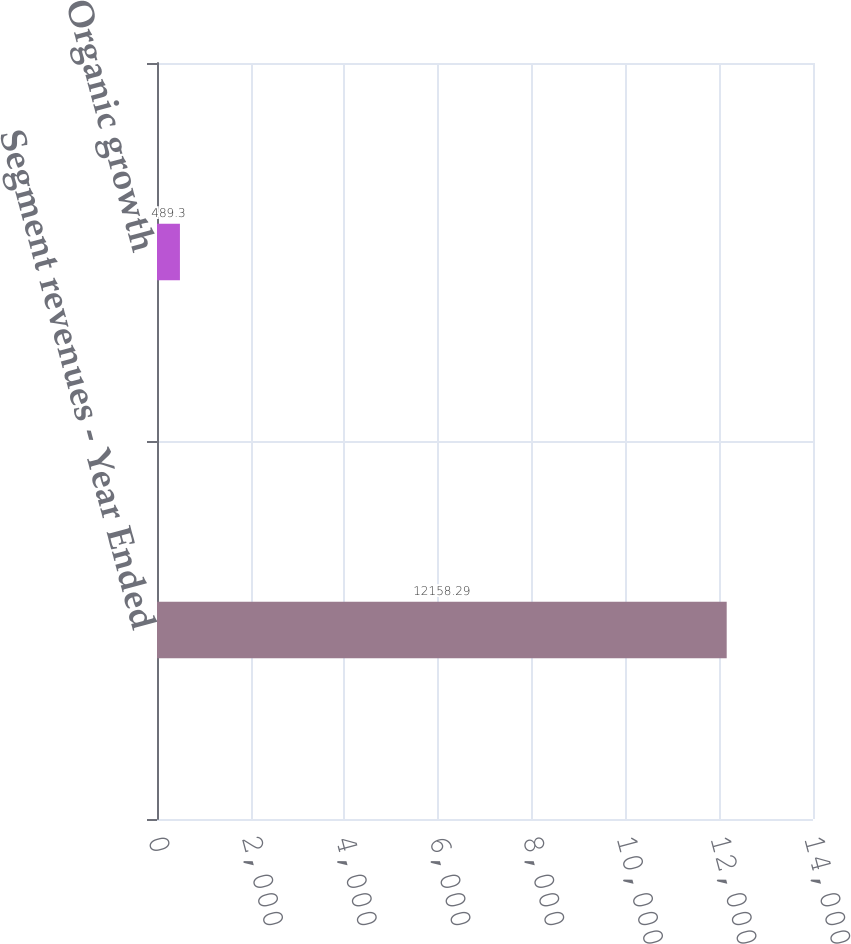Convert chart to OTSL. <chart><loc_0><loc_0><loc_500><loc_500><bar_chart><fcel>Segment revenues - Year Ended<fcel>Organic growth<nl><fcel>12158.3<fcel>489.3<nl></chart> 